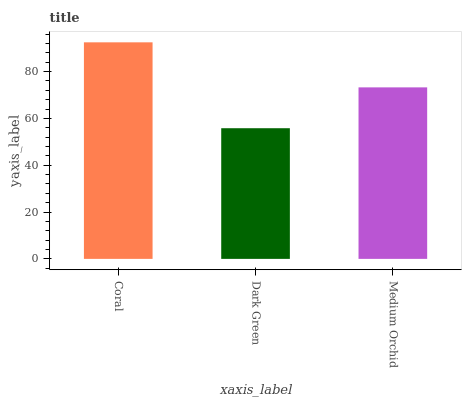Is Dark Green the minimum?
Answer yes or no. Yes. Is Coral the maximum?
Answer yes or no. Yes. Is Medium Orchid the minimum?
Answer yes or no. No. Is Medium Orchid the maximum?
Answer yes or no. No. Is Medium Orchid greater than Dark Green?
Answer yes or no. Yes. Is Dark Green less than Medium Orchid?
Answer yes or no. Yes. Is Dark Green greater than Medium Orchid?
Answer yes or no. No. Is Medium Orchid less than Dark Green?
Answer yes or no. No. Is Medium Orchid the high median?
Answer yes or no. Yes. Is Medium Orchid the low median?
Answer yes or no. Yes. Is Coral the high median?
Answer yes or no. No. Is Dark Green the low median?
Answer yes or no. No. 